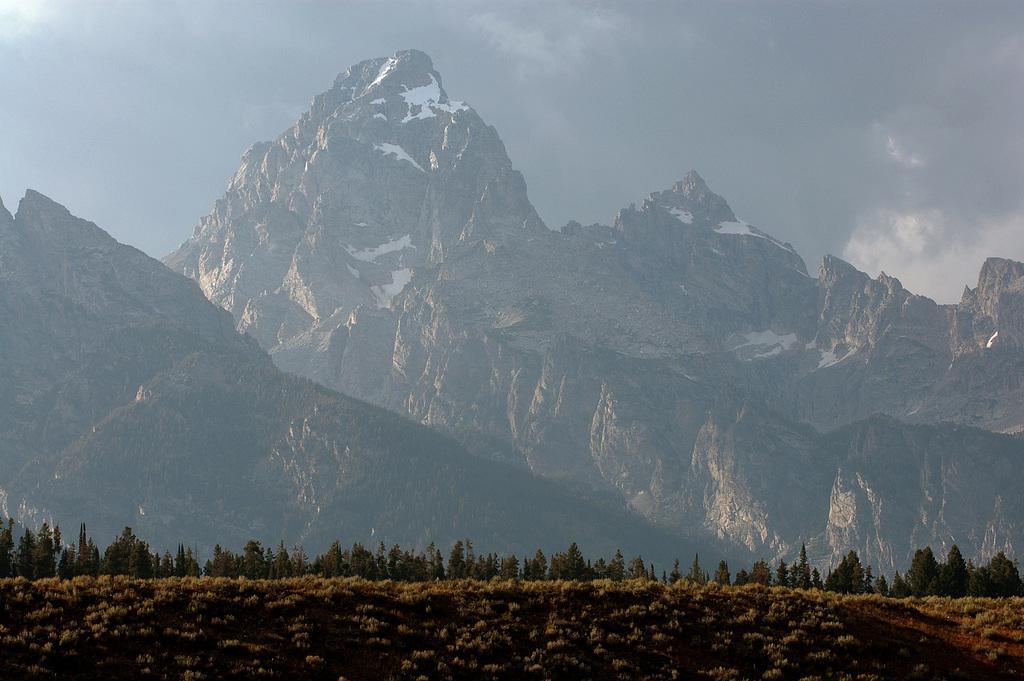How would you summarize this image in a sentence or two? In this picture I can see there is grass on the floor, there are trees in the backdrop, there are mountains in the backdrop, it has some snow on it and the sky is cloudy. 